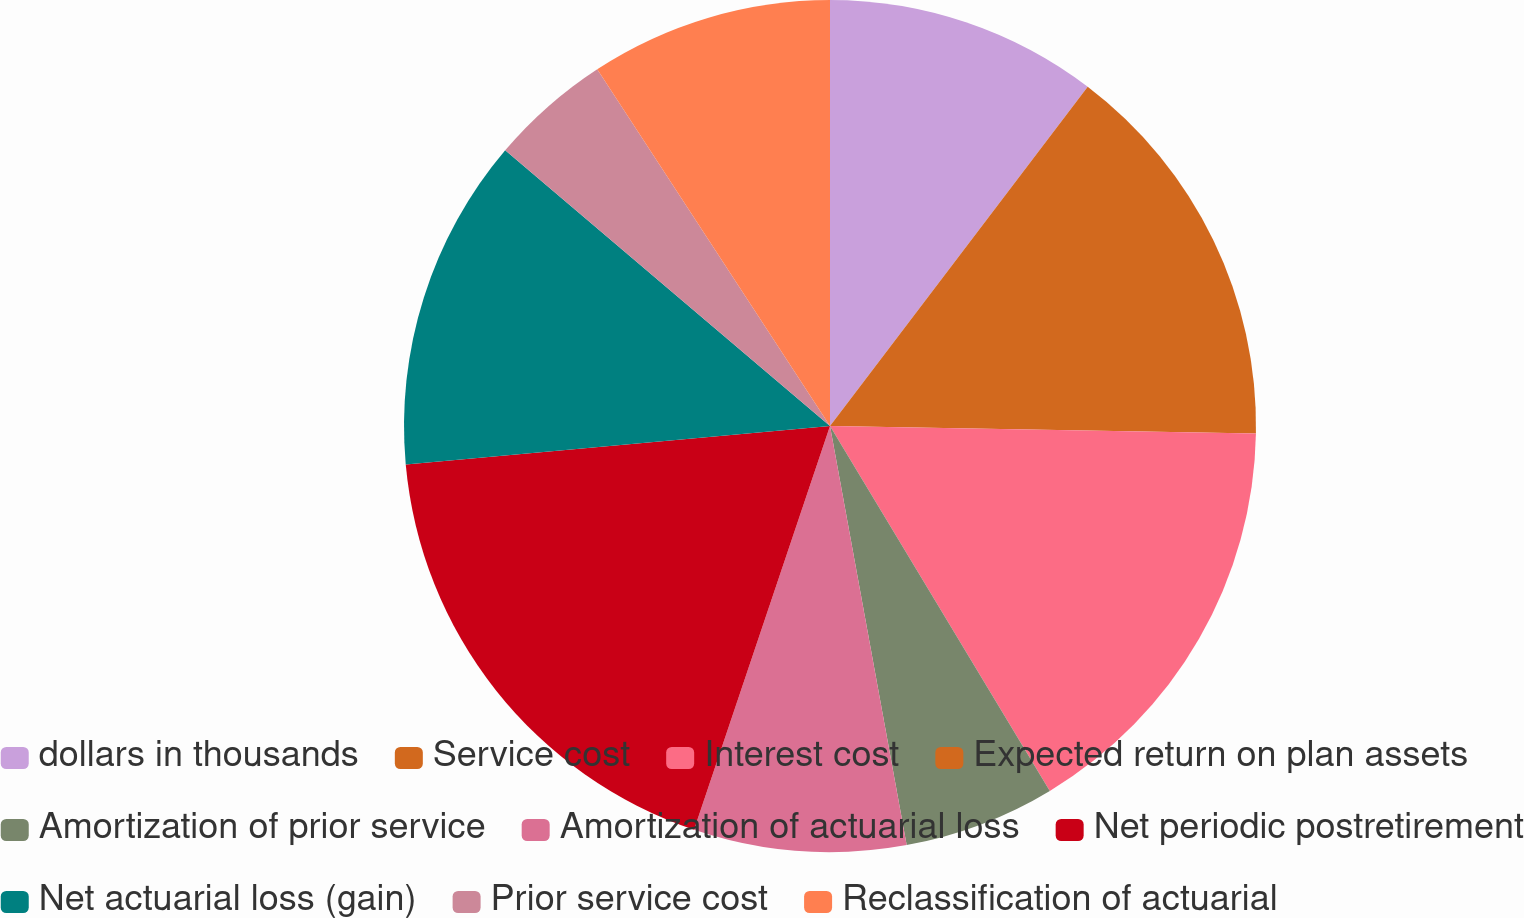Convert chart. <chart><loc_0><loc_0><loc_500><loc_500><pie_chart><fcel>dollars in thousands<fcel>Service cost<fcel>Interest cost<fcel>Expected return on plan assets<fcel>Amortization of prior service<fcel>Amortization of actuarial loss<fcel>Net periodic postretirement<fcel>Net actuarial loss (gain)<fcel>Prior service cost<fcel>Reclassification of actuarial<nl><fcel>10.34%<fcel>14.94%<fcel>16.09%<fcel>0.0%<fcel>5.75%<fcel>8.05%<fcel>18.39%<fcel>12.64%<fcel>4.6%<fcel>9.2%<nl></chart> 